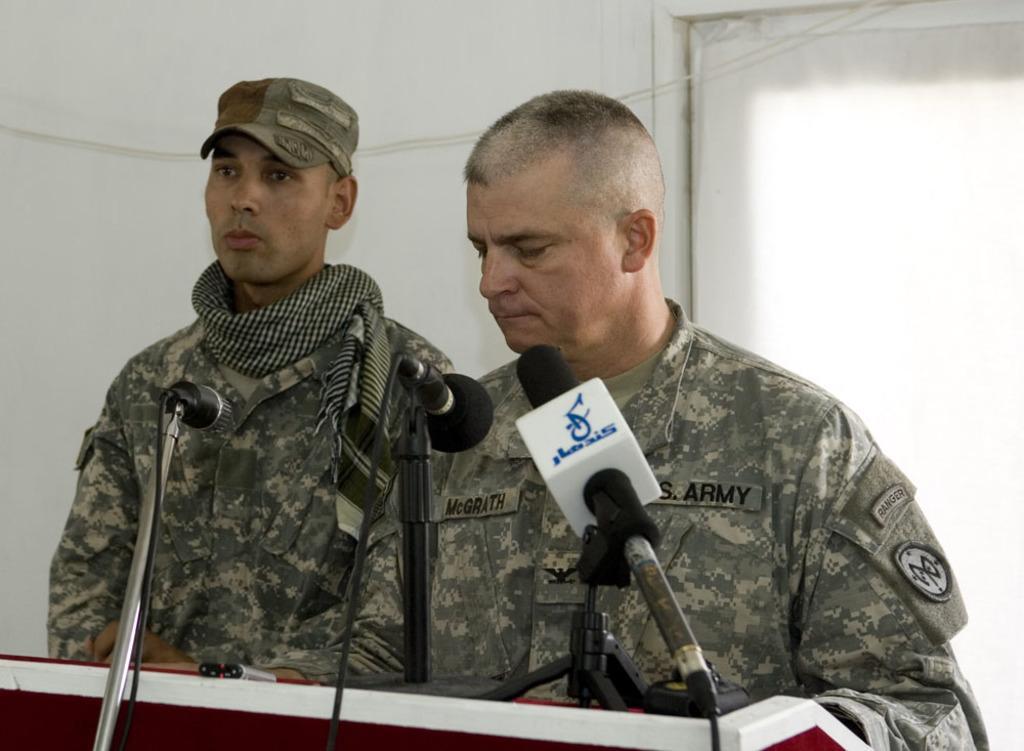Can you describe this image briefly? In this image two persons wearing a uniform are behind the podium which is having few miles on it. Before the podium there is mike stand. Left side person is wearing scarf and a cap. Behind them there is a wall having a door to it. 